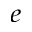Convert formula to latex. <formula><loc_0><loc_0><loc_500><loc_500>^ { \, e }</formula> 